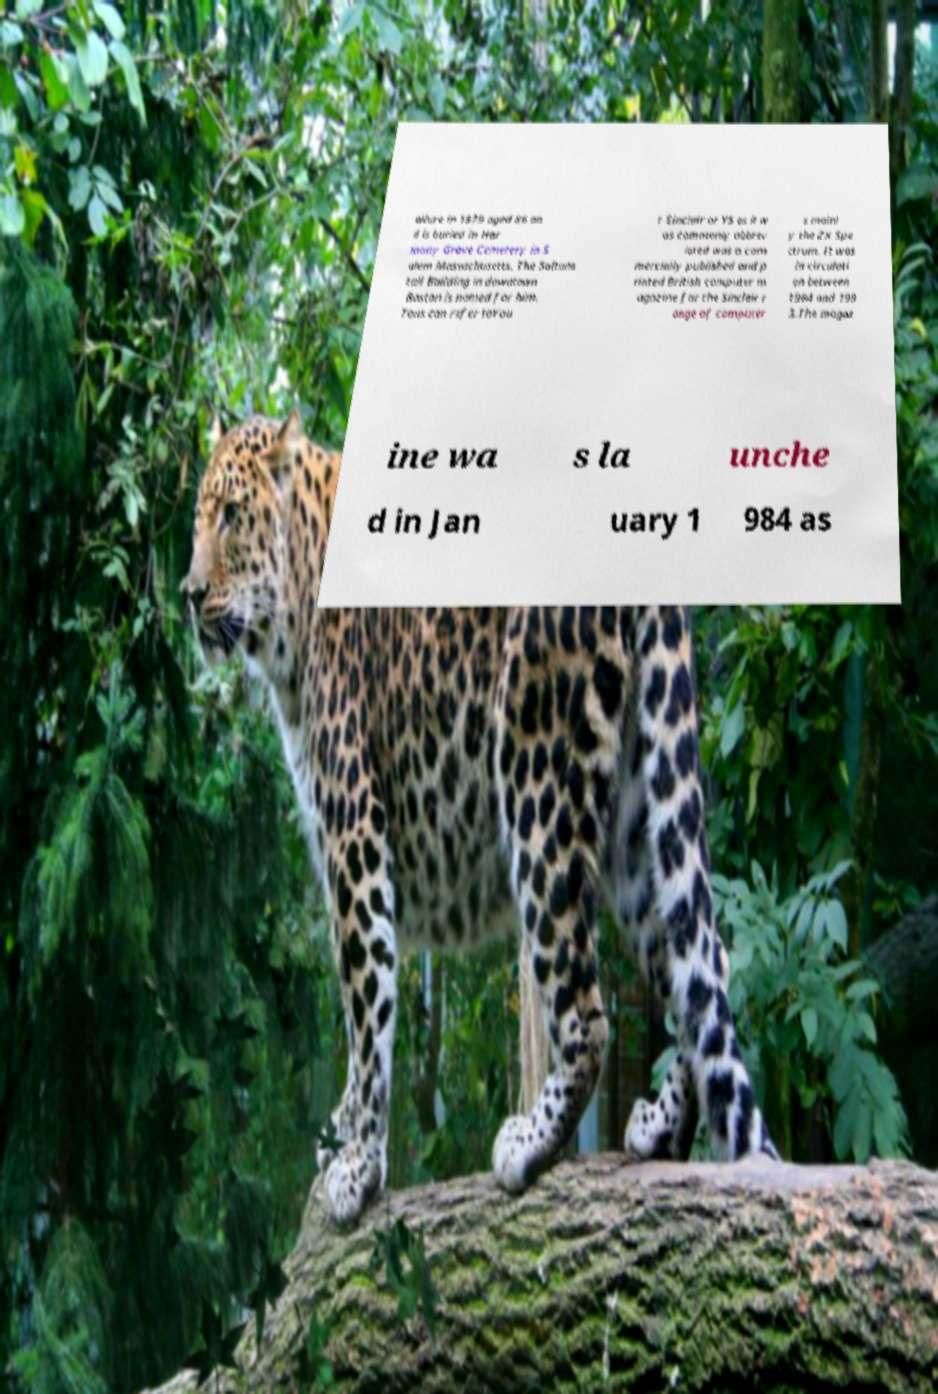Can you accurately transcribe the text from the provided image for me? ailure in 1979 aged 86 an d is buried in Har mony Grove Cemetery in S alem Massachusetts. The Saltons tall Building in downtown Boston is named for him. Tons can refer toYou r Sinclair or YS as it w as commonly abbrev iated was a com mercially published and p rinted British computer m agazine for the Sinclair r ange of computer s mainl y the ZX Spe ctrum. It was in circulati on between 1984 and 199 3.The magaz ine wa s la unche d in Jan uary 1 984 as 